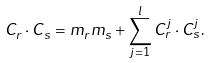<formula> <loc_0><loc_0><loc_500><loc_500>C _ { r } \cdot C _ { s } = m _ { r } m _ { s } + \sum _ { j = 1 } ^ { l } C _ { r } ^ { j } \cdot C _ { s } ^ { j } .</formula> 